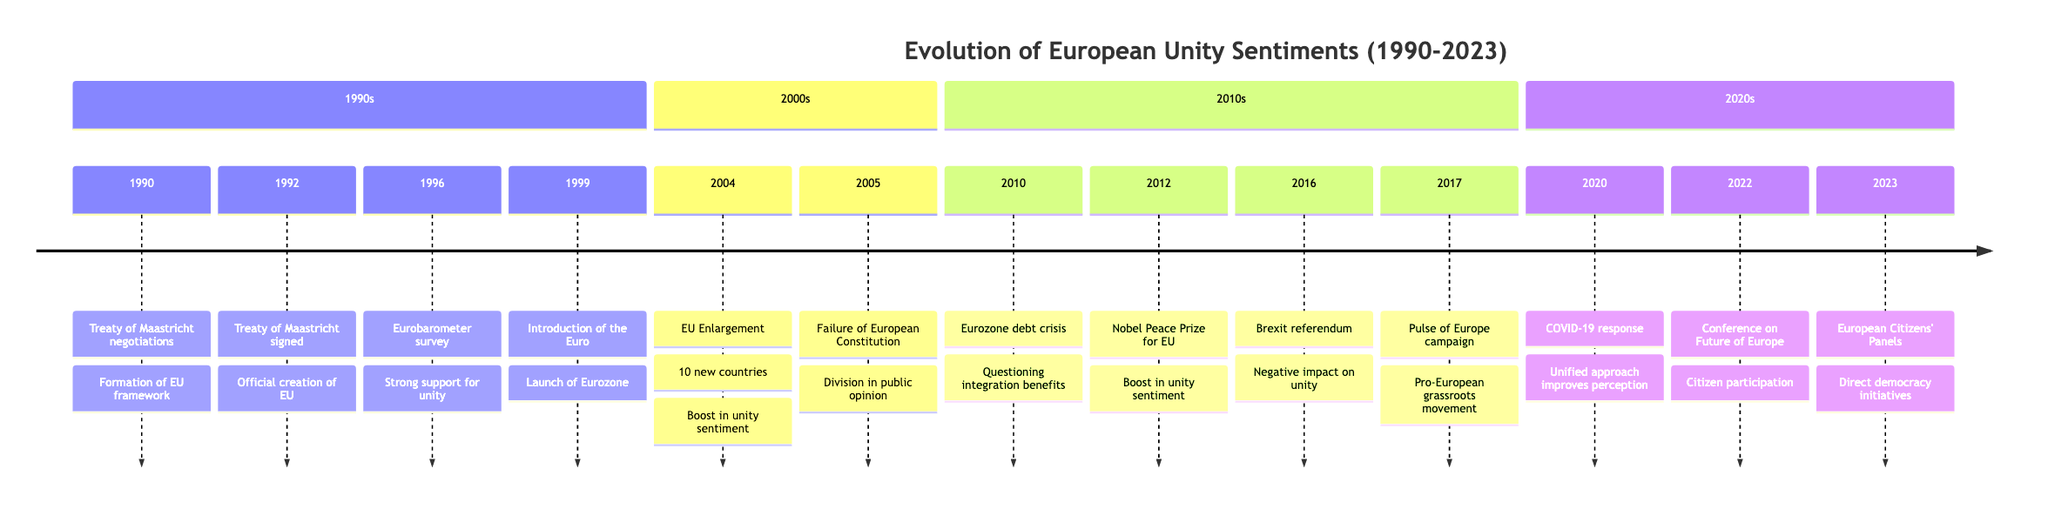What event marked the official creation of the European Union? The diagram indicates that the event marking the official creation of the European Union is the signing of the Treaty of Maastricht in 1992. This is explicitly stated in the timeline.
Answer: Treaty of Maastricht signed How many new countries joined the EU in 2004? From the timeline, it is specified that 10 new countries joined the EU in 2004, which directly answers the question.
Answer: 10 What event happened in 2016 that negatively impacted unity sentiment? The timeline shows that the Brexit referendum occurred in 2016, and it is explicitly labeled as having a significant negative impact on unity sentiment.
Answer: Brexit referendum Which event in 2012 boosted unity sentiment? According to the timeline, the Nobel Peace Prize awarded to the EU in 2012 is stated to have boosted unity sentiment, which provides the answer.
Answer: Nobel Peace Prize for the EU What grassroots movement emerged in 2017? The timeline mentions the "Pulse of Europe campaign" as a grassroots pro-European movement that emerged in 2017. Therefore, it answers the question directly.
Answer: Pulse of Europe campaign What major economic event occurred in 2010? The timeline identifies the Eurozone debt crisis as the significant economic event that happened in 2010, which pertains to the question about major events.
Answer: Eurozone debt crisis How did the COVID-19 response in 2020 affect public perception of the EU? The timeline notes that the United approach to the pandemic through a Recovery Fund in 2020 improved public perception of the EU, leading to a positive sentiment.
Answer: Improved perception of EU Which event in 2022 involved citizen participation shaping EU policies? The timeline clearly states that the Conference on the Future of Europe in 2022 involved citizens participating in shaping EU policies, which directly answers the question.
Answer: Conference on the Future of Europe 